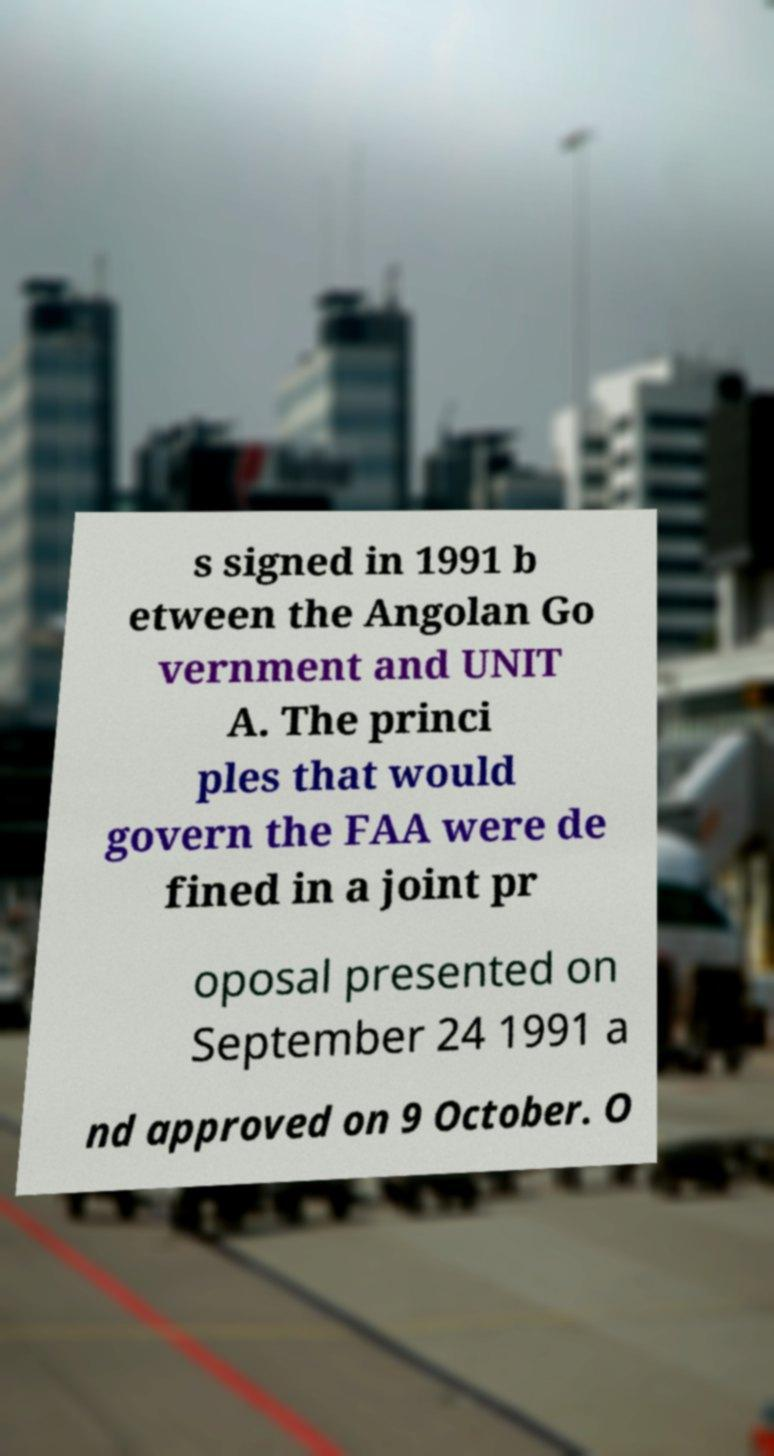Can you read and provide the text displayed in the image?This photo seems to have some interesting text. Can you extract and type it out for me? s signed in 1991 b etween the Angolan Go vernment and UNIT A. The princi ples that would govern the FAA were de fined in a joint pr oposal presented on September 24 1991 a nd approved on 9 October. O 